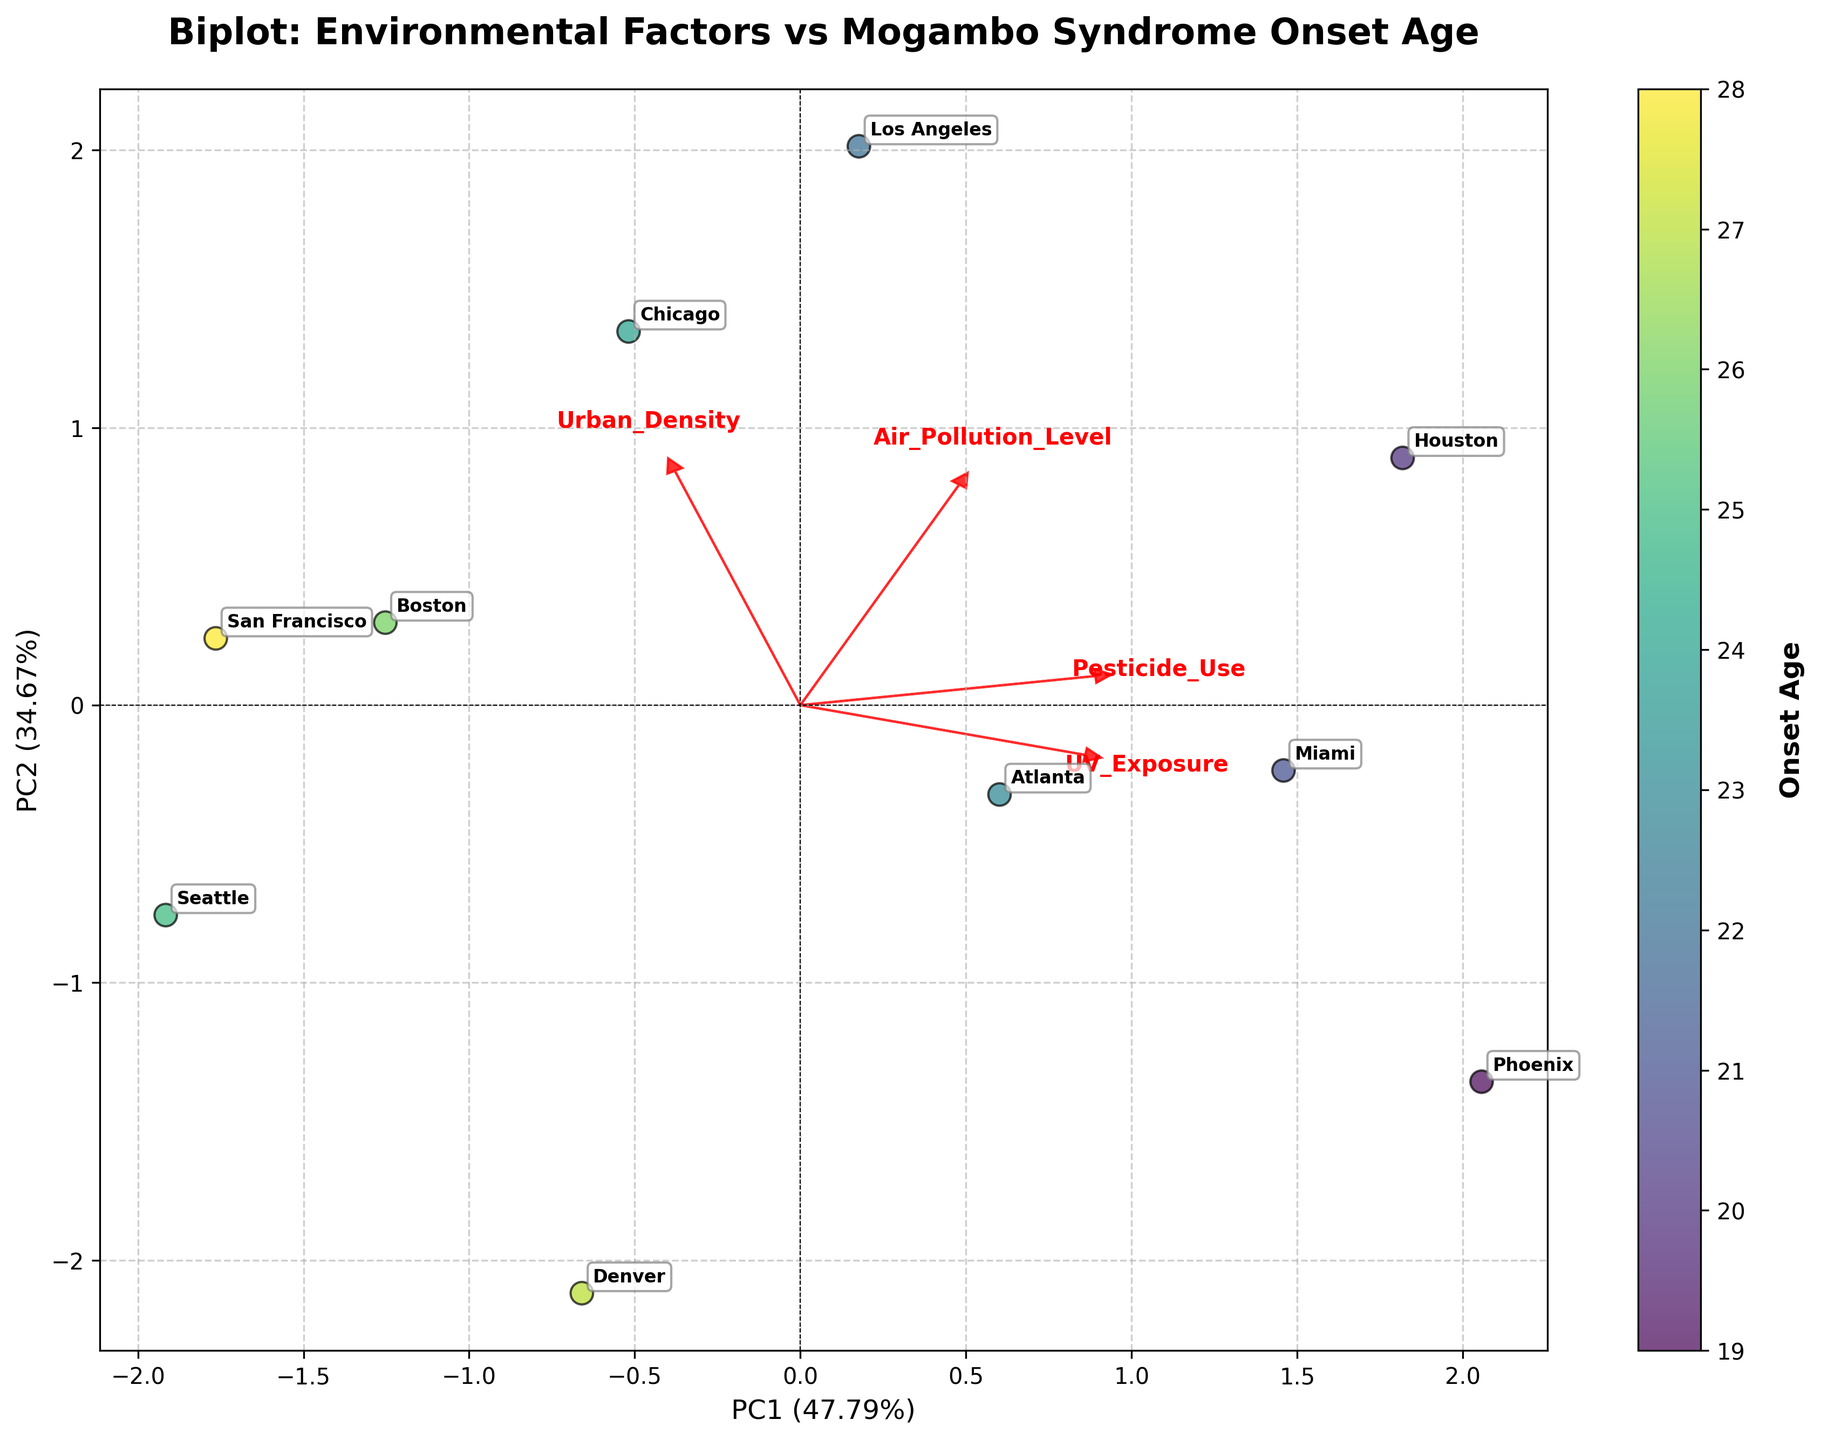What is the title of the plot? The title of the plot is displayed at the top and it reads "Biplot: Environmental Factors vs Mogambo Syndrome Onset Age".
Answer: Biplot: Environmental Factors vs Mogambo Syndrome Onset Age What does the color bar on the right side of the plot represent? The color bar shows a gradient from low to high onset ages, indicating that the colors of the data points are proportional to the Mogambo Syndrome onset ages.
Answer: Onset Age How many data points are represented in the plot? By counting the number of scatter points (each city), we can see that there are 10 data points represented in the plot.
Answer: 10 Which environmental factor has the largest arrow in the biplot? By observing the length of the arrows representing the environmental factors, the arrow for 'Urban Density' is the longest.
Answer: Urban Density Which city corresponds to the highest onset age shown in the plot? The highest onset age corresponds to the color at the end of the color gradient. By locating the city with that color, we see that San Francisco has the highest onset age.
Answer: San Francisco How do 'Air Pollution Level' and 'UV Exposure' compare in terms of their relationship to PC1 and PC2? 'Air Pollution Level' has a strong positive direction along PC1 and a slight negative along PC2, while 'UV Exposure' has a positive direction along both PC1 and PC2.
Answer: Air Pollution Level: PC1 (positive), PC2 (slight negative); UV Exposure: PC1 (positive), PC2 (positive) What is the percentage of variance explained by PC1 and PC2 together? The percentages explained by PC1 and PC2 are given in the axis labels; summing them up gives the total explained variance: 47.3% + 23.9% = 71.2%.
Answer: 71.2% Between 'Pesticide Use' and 'Urban Density', which factor has a stronger association with PC1? By observing the length and direction of the arrows, 'Urban Density' has a longer arrow along PC1 than 'Pesticide Use' does, indicating a stronger association.
Answer: Urban Density Is there any environmental factor that has a negative relationship with PC2? By observing the directions of the arrows, 'Air Pollution Level' shows a slightly negative relationship with PC2.
Answer: Air Pollution Level 